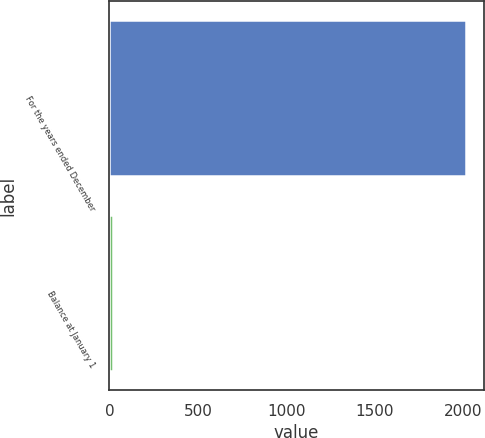Convert chart to OTSL. <chart><loc_0><loc_0><loc_500><loc_500><bar_chart><fcel>For the years ended December<fcel>Balance at January 1<nl><fcel>2016<fcel>22<nl></chart> 